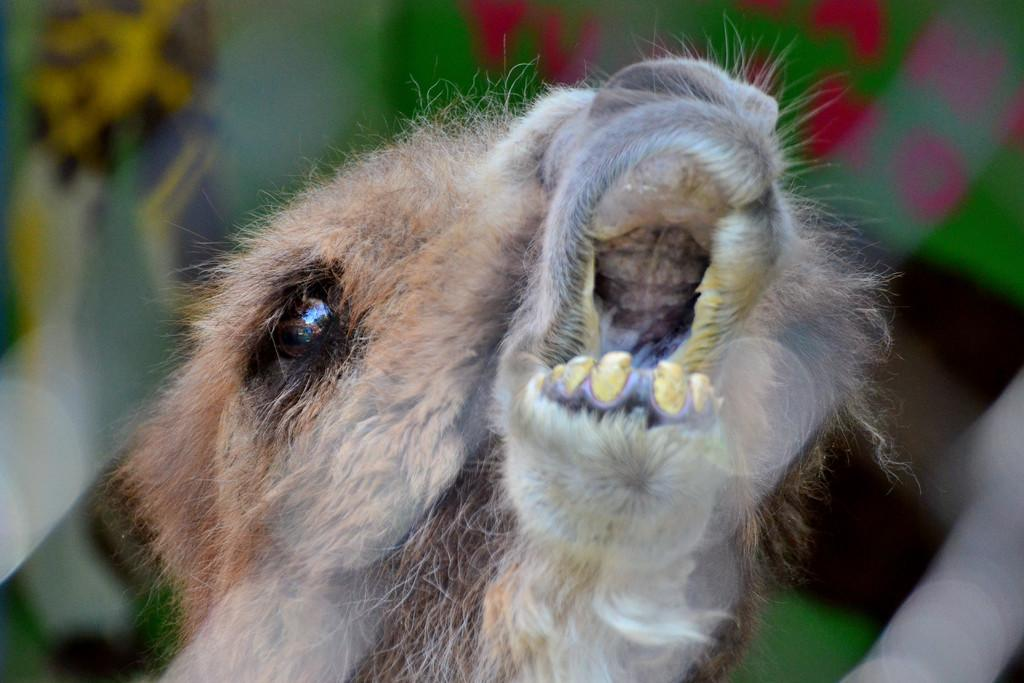What is the main subject in front of the image? There is an animal in front of the image. Can you describe the background of the image? The background of the image is blurred. Where is the throne located in the image? There is no throne present in the image. What type of play is the animal participating in the image? The image does not depict any play or activity involving the animal. 